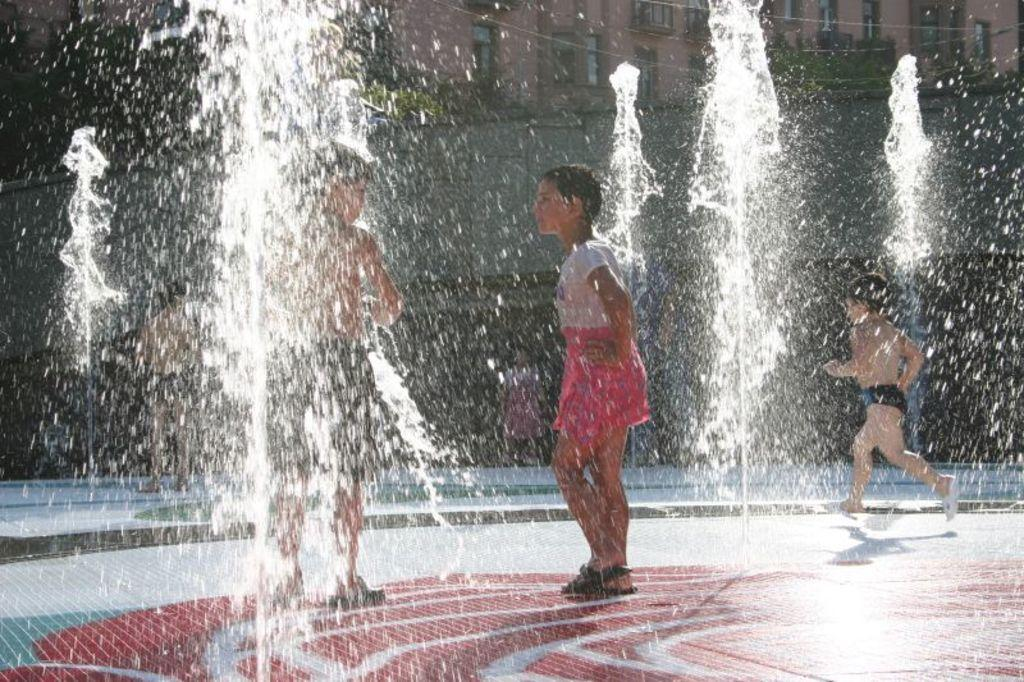How many people are present in the image? There are four persons in the image. What is located in the front of the image? There is a fountain in the front of the image. What can be seen in the background of the image? There is a building in the background of the image. What is the primary element visible in the image? Water is visible in the image. What type of button is being compared by the persons in the image? There is no button or comparison activity present in the image. Can you tell me how many cats are visible in the image? There are no cats present in the image. 